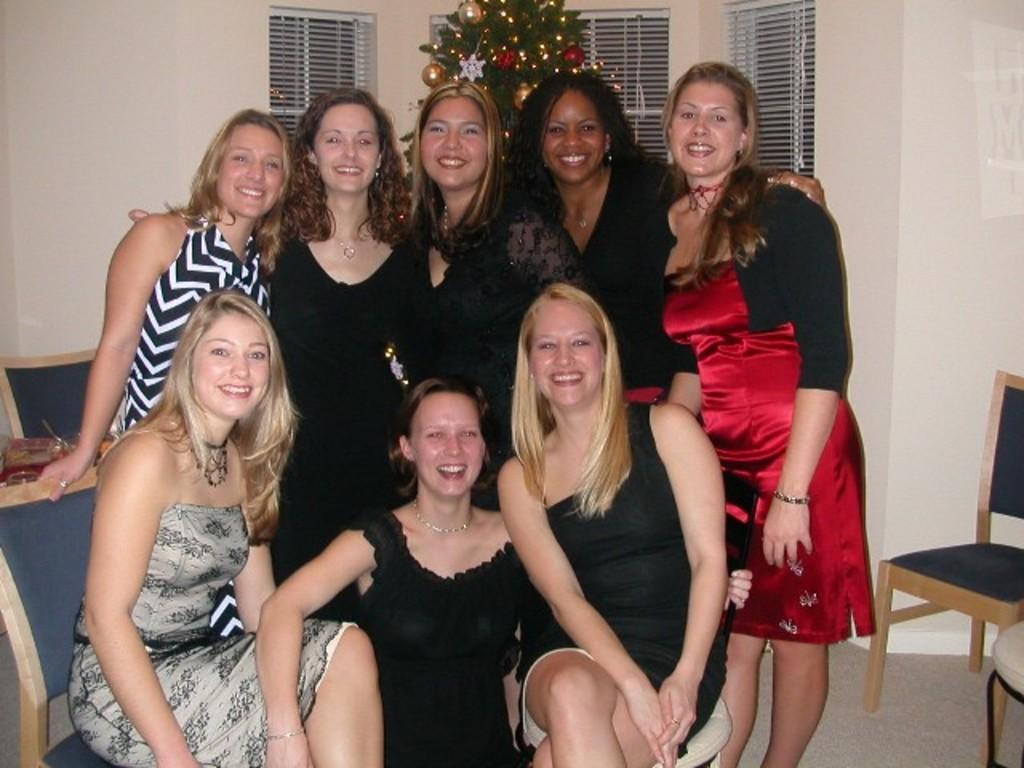In one or two sentences, can you explain what this image depicts? As we can see in the image there is a wall, window, Christmas tree and few people standing and sitting over here. 